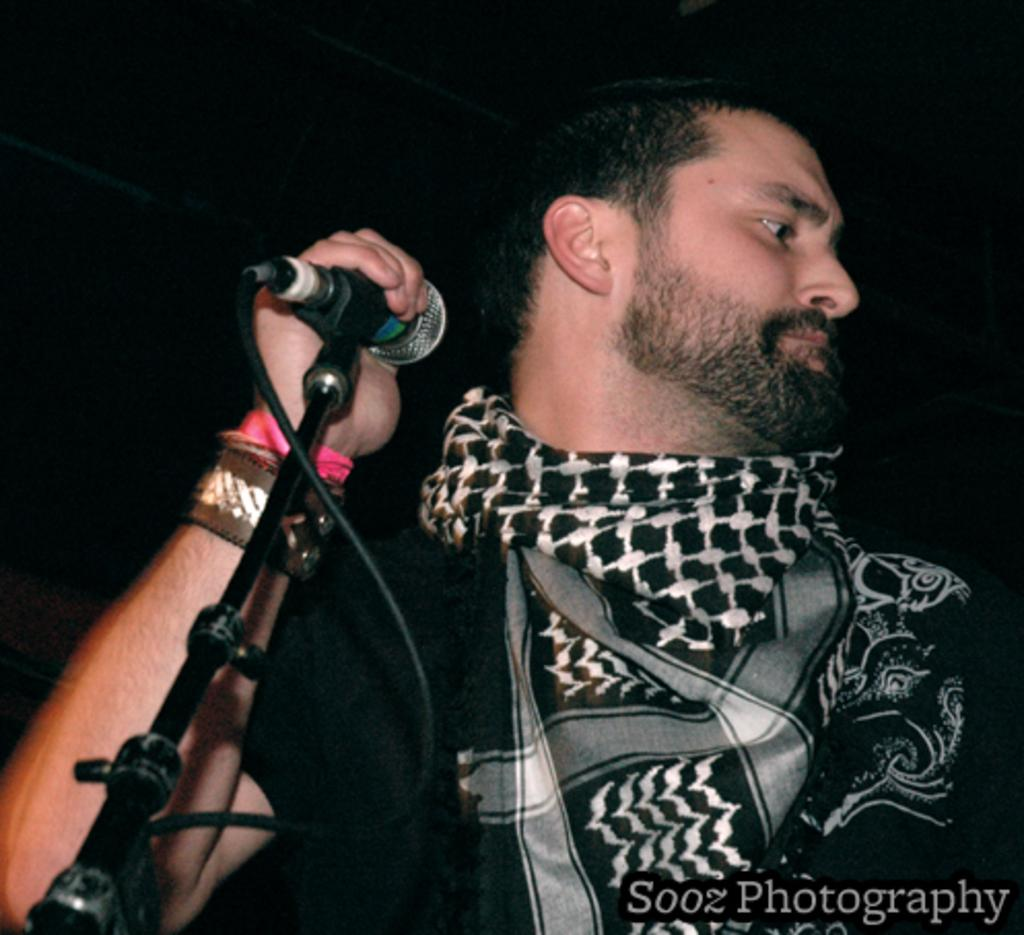What is the main subject of the image? The main subject of the image is a man. What is the man holding in the image? The man is holding a microphone. What is the man wearing in the image? The man is wearing a black t-shirt. What is the name of the man's mom in the image? There is no information about the man's mom in the image, so we cannot determine her name. 